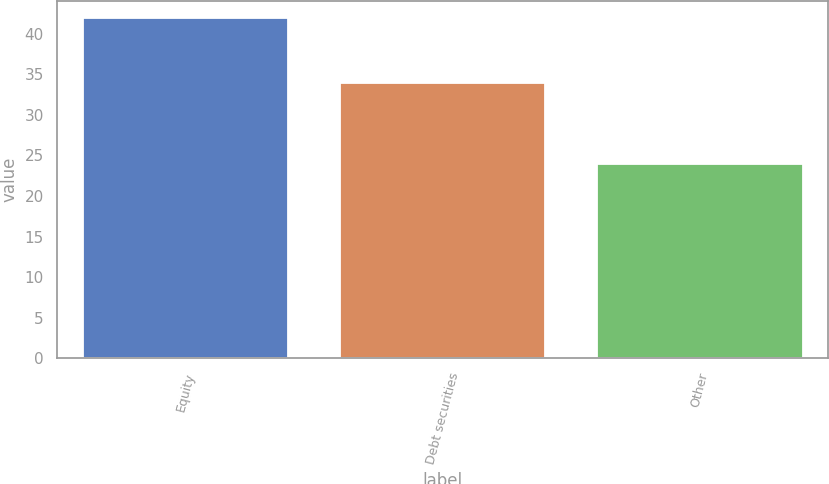Convert chart. <chart><loc_0><loc_0><loc_500><loc_500><bar_chart><fcel>Equity<fcel>Debt securities<fcel>Other<nl><fcel>42<fcel>34<fcel>24<nl></chart> 